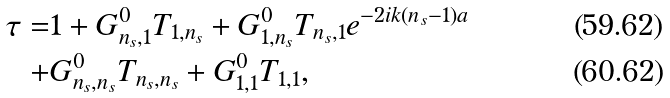<formula> <loc_0><loc_0><loc_500><loc_500>\tau = & 1 + G ^ { 0 } _ { n _ { s } , 1 } T _ { 1 , n _ { s } } + G ^ { 0 } _ { 1 , n _ { s } } T _ { n _ { s } , 1 } e ^ { - 2 i k ( n _ { s } - 1 ) a } \\ + & G ^ { 0 } _ { n _ { s } , n _ { s } } T _ { n _ { s } , n _ { s } } + G ^ { 0 } _ { 1 , 1 } T _ { 1 , 1 } ,</formula> 